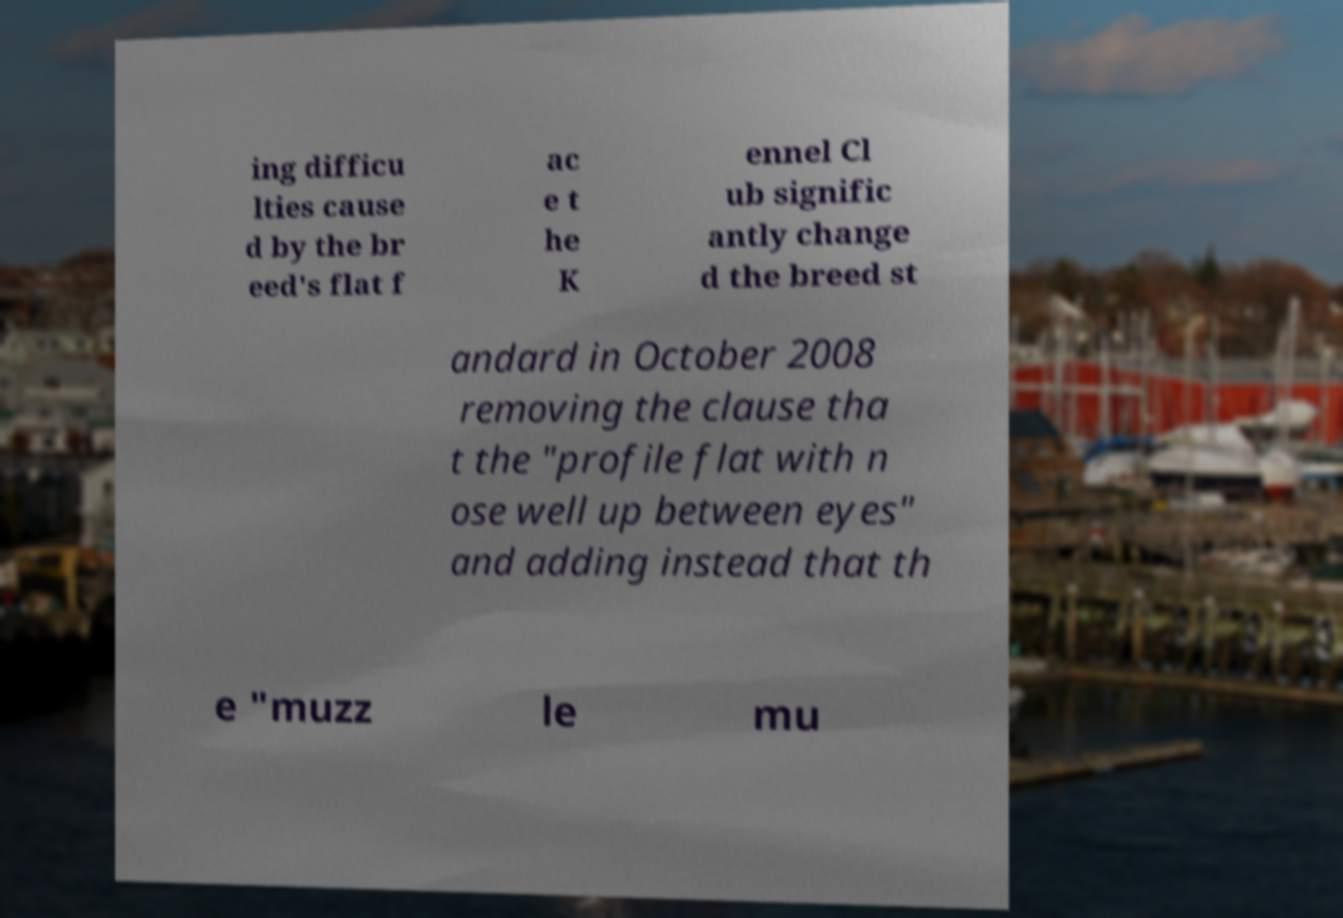I need the written content from this picture converted into text. Can you do that? ing difficu lties cause d by the br eed's flat f ac e t he K ennel Cl ub signific antly change d the breed st andard in October 2008 removing the clause tha t the "profile flat with n ose well up between eyes" and adding instead that th e "muzz le mu 